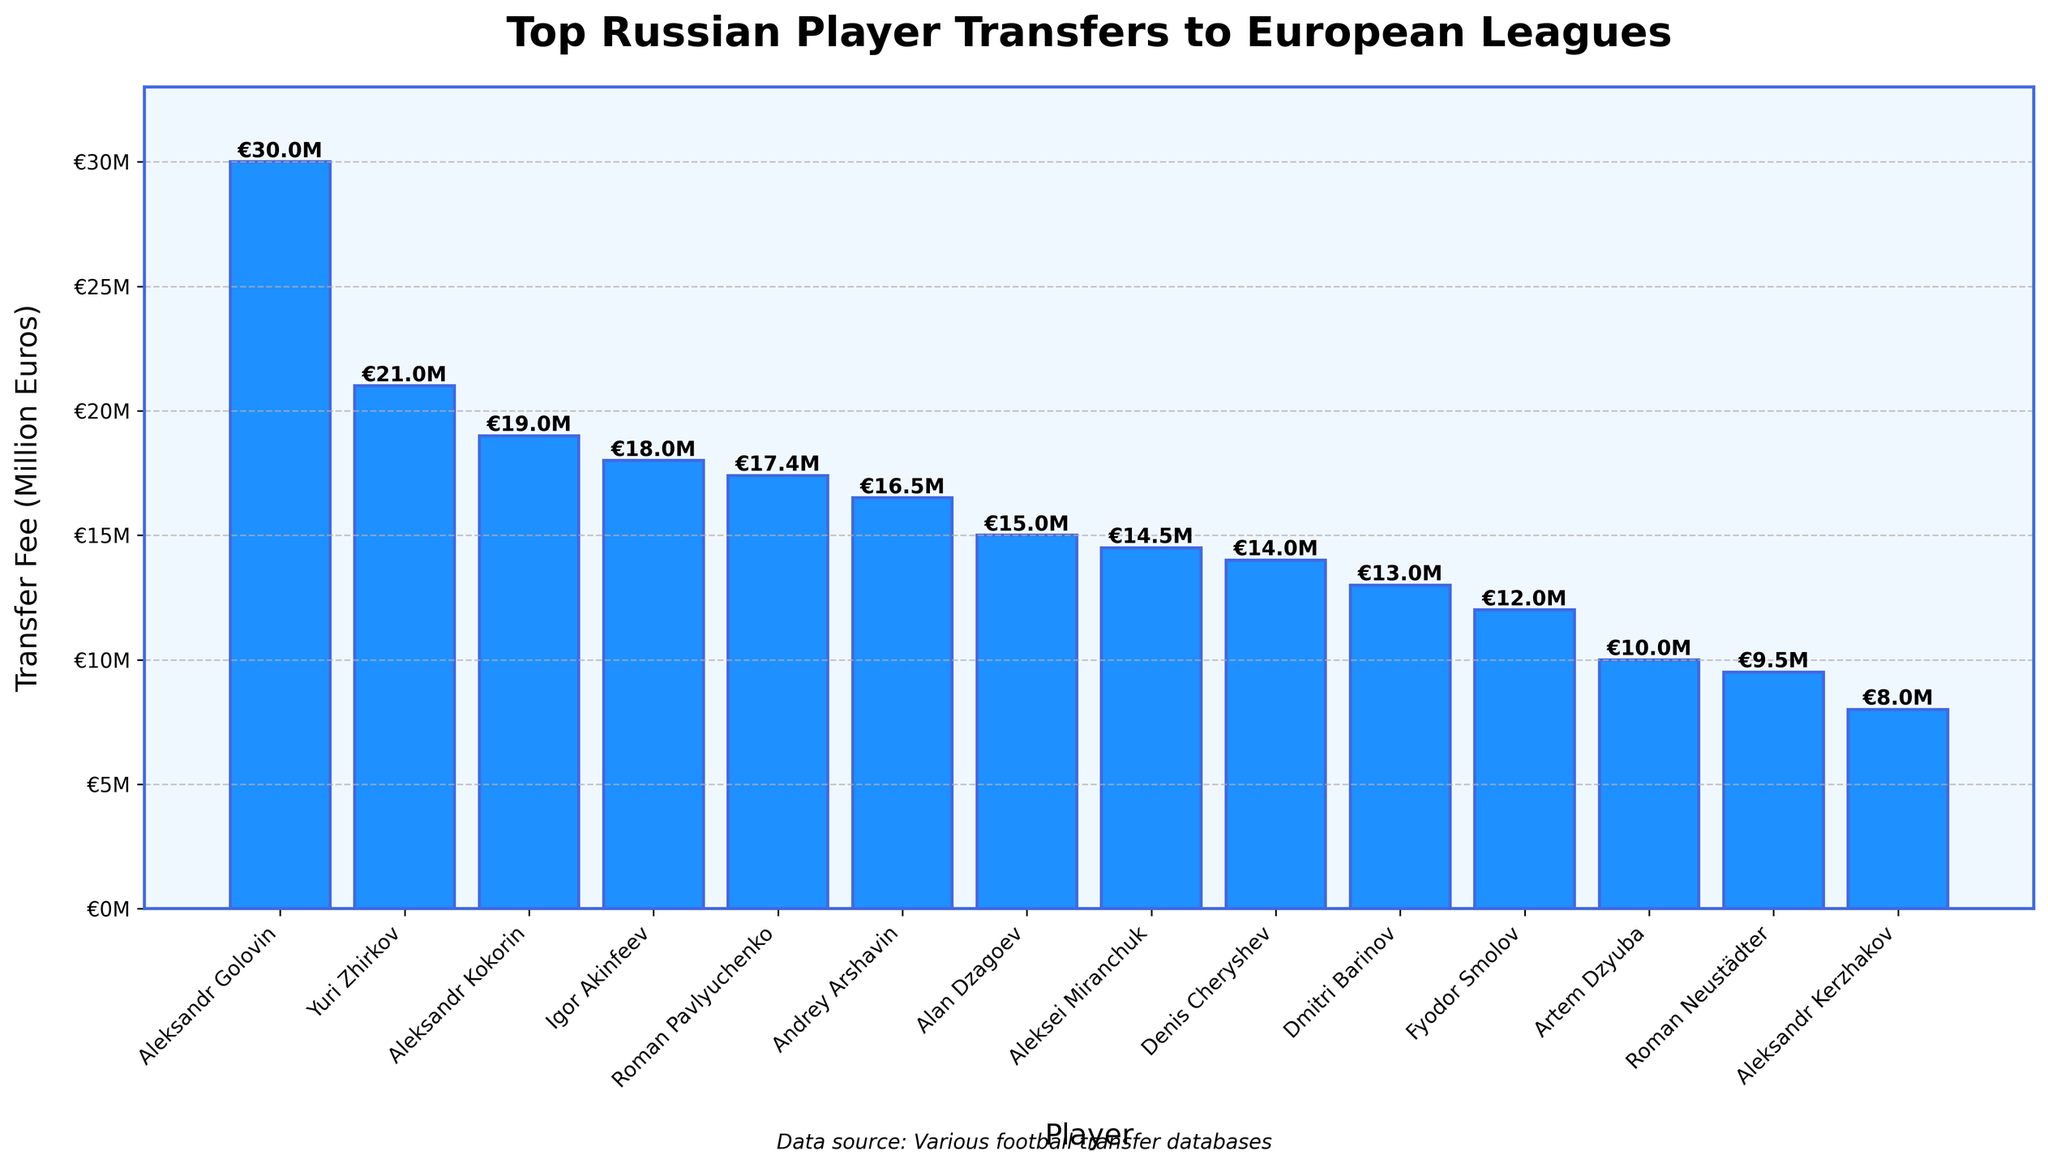Which player has the highest transfer fee? The bar corresponding to Aleksandr Golovin is the tallest, indicating the highest transfer fee.
Answer: Aleksandr Golovin Who transferred for a higher fee, Roman Pavlyuchenko or Andrey Arshavin? Roman Pavlyuchenko's bar is slightly higher than Andrey Arshavin's bar.
Answer: Roman Pavlyuchenko What is the combined transfer fee of Yuri Zhirkov and Igor Akinfeev? Yuri Zhirkov's transfer fee is €21M and Igor Akinfeev's transfer fee is €18M. Summing them gives 21 + 18.
Answer: €39M Which player transferred to Chelsea? By examining the x-axis labels and bars, Yuri Zhirkov is the player who transferred to Chelsea.
Answer: Yuri Zhirkov How much more was Aleksandr Golovin's transfer fee compared to Aleksei Miranchuk's? Aleksandr Golovin's transfer fee is €30M and Aleksei Miranchuk's transfer fee is €14.5M. The difference is 30 - 14.5.
Answer: €15.5M What is the average transfer fee of the top three highest transfers shown? The top three transfers are Aleksandr Golovin (€30M), Yuri Zhirkov (€21M), and Igor Akinfeev (€18M). The average is (30 + 21 + 18) / 3.
Answer: €23M Which player transferred for a fee less than €15M but more than €10M and to which club? Aleksei Miranchuk (€14.5M) and Denis Cheryshev (€14M) fit the criteria. Miranchuk went to Atalanta, and Cheryshev went to Valencia.
Answer: Aleksei Miranchuk to Atalanta, Denis Cheryshev to Valencia Which two players have the closest transfer fees? The bars for Andrey Arshavin (€16.5M) and Roman Pavlyuchenko (€17.4M) are nearly the same height.
Answer: Andrey Arshavin and Roman Pavlyuchenko Which player transferred to Sevilla? By looking at the labels, Aleksandr Kerzhakov is the player who transferred to Sevilla.
Answer: Aleksandr Kerzhakov 